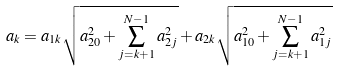Convert formula to latex. <formula><loc_0><loc_0><loc_500><loc_500>a _ { k } = a _ { 1 k } \sqrt { a ^ { 2 } _ { 2 0 } + \sum ^ { N - 1 } _ { j = k + 1 } a ^ { 2 } _ { 2 j } } + a _ { 2 k } \sqrt { a ^ { 2 } _ { 1 0 } + \sum ^ { N - 1 } _ { j = k + 1 } a ^ { 2 } _ { 1 j } }</formula> 